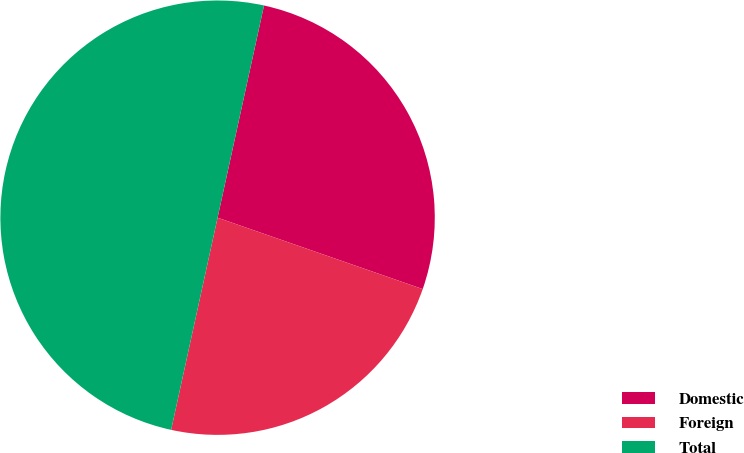<chart> <loc_0><loc_0><loc_500><loc_500><pie_chart><fcel>Domestic<fcel>Foreign<fcel>Total<nl><fcel>26.9%<fcel>23.1%<fcel>50.0%<nl></chart> 